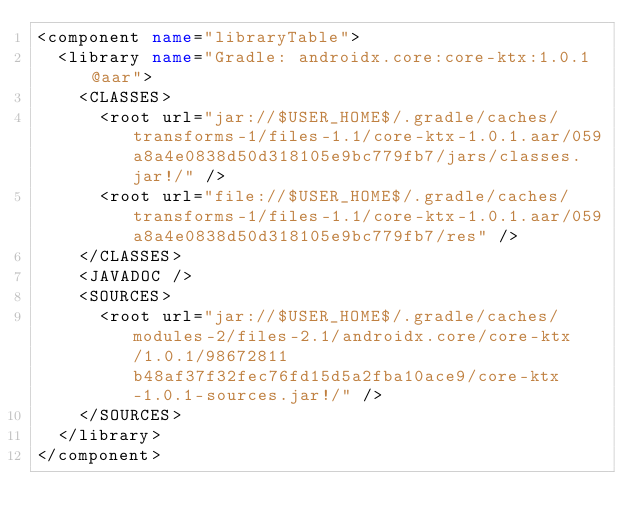Convert code to text. <code><loc_0><loc_0><loc_500><loc_500><_XML_><component name="libraryTable">
  <library name="Gradle: androidx.core:core-ktx:1.0.1@aar">
    <CLASSES>
      <root url="jar://$USER_HOME$/.gradle/caches/transforms-1/files-1.1/core-ktx-1.0.1.aar/059a8a4e0838d50d318105e9bc779fb7/jars/classes.jar!/" />
      <root url="file://$USER_HOME$/.gradle/caches/transforms-1/files-1.1/core-ktx-1.0.1.aar/059a8a4e0838d50d318105e9bc779fb7/res" />
    </CLASSES>
    <JAVADOC />
    <SOURCES>
      <root url="jar://$USER_HOME$/.gradle/caches/modules-2/files-2.1/androidx.core/core-ktx/1.0.1/98672811b48af37f32fec76fd15d5a2fba10ace9/core-ktx-1.0.1-sources.jar!/" />
    </SOURCES>
  </library>
</component></code> 